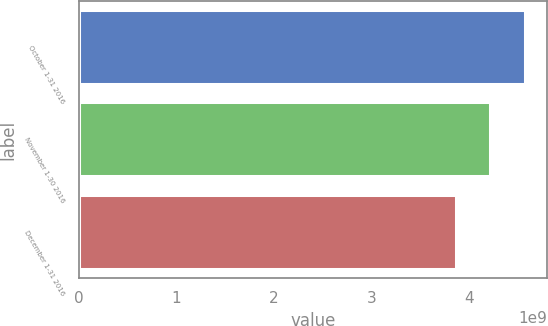<chart> <loc_0><loc_0><loc_500><loc_500><bar_chart><fcel>October 1-31 2016<fcel>November 1-30 2016<fcel>December 1-31 2016<nl><fcel>4.57114e+09<fcel>4.21351e+09<fcel>3.85857e+09<nl></chart> 